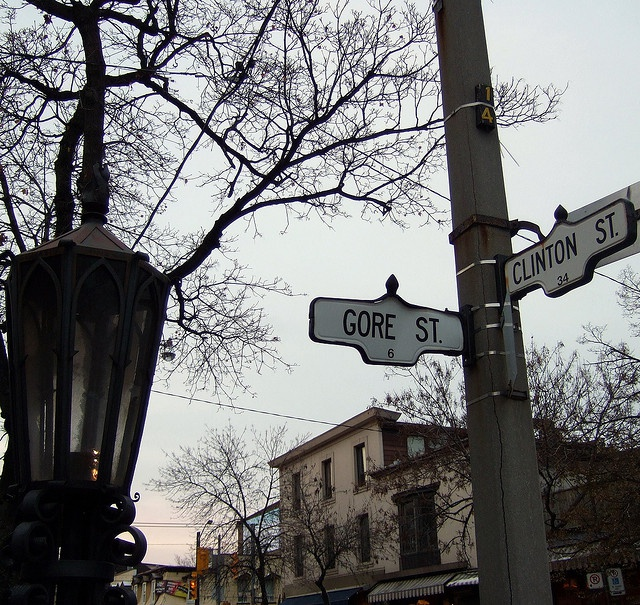Describe the objects in this image and their specific colors. I can see a traffic light in lavender, black, maroon, olive, and gray tones in this image. 